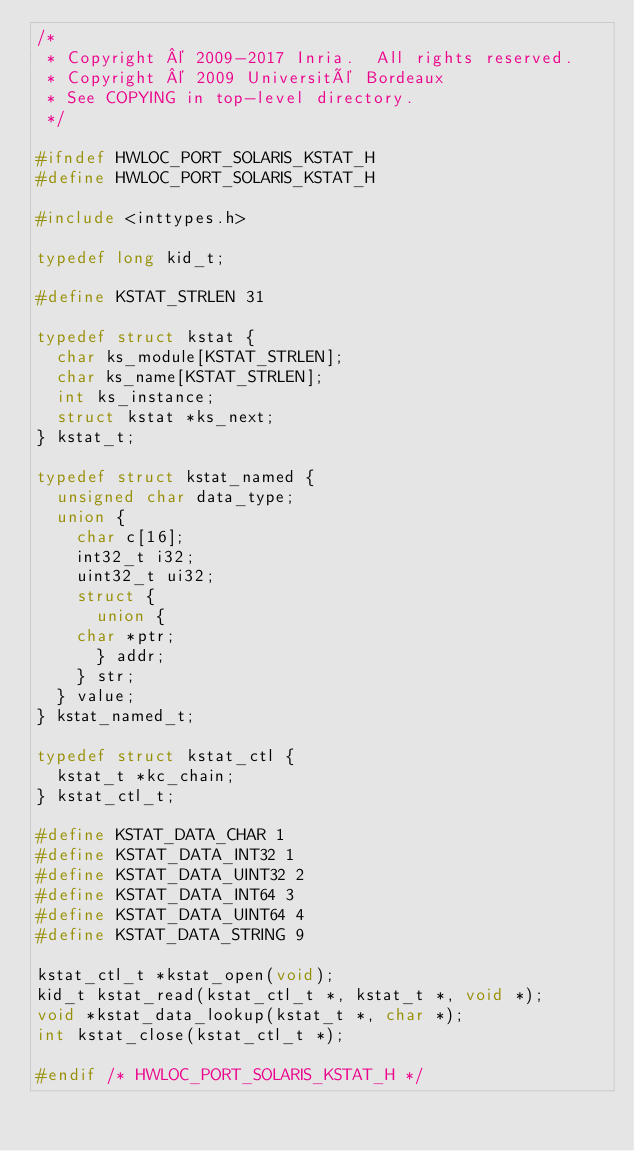Convert code to text. <code><loc_0><loc_0><loc_500><loc_500><_C_>/*
 * Copyright © 2009-2017 Inria.  All rights reserved.
 * Copyright © 2009 Université Bordeaux
 * See COPYING in top-level directory.
 */

#ifndef HWLOC_PORT_SOLARIS_KSTAT_H
#define HWLOC_PORT_SOLARIS_KSTAT_H

#include <inttypes.h>

typedef long kid_t;

#define KSTAT_STRLEN 31

typedef struct kstat {
  char ks_module[KSTAT_STRLEN];
  char ks_name[KSTAT_STRLEN];
  int ks_instance;
  struct kstat *ks_next;
} kstat_t;

typedef struct kstat_named {
  unsigned char data_type;
  union {
    char c[16];
    int32_t i32;
    uint32_t ui32;
    struct {
      union {
	char *ptr;
      } addr;
    } str;
  } value;
} kstat_named_t;

typedef struct kstat_ctl {
  kstat_t *kc_chain;
} kstat_ctl_t;

#define KSTAT_DATA_CHAR 1
#define KSTAT_DATA_INT32 1
#define KSTAT_DATA_UINT32 2
#define KSTAT_DATA_INT64 3
#define KSTAT_DATA_UINT64 4
#define KSTAT_DATA_STRING 9

kstat_ctl_t *kstat_open(void);
kid_t kstat_read(kstat_ctl_t *, kstat_t *, void *);
void *kstat_data_lookup(kstat_t *, char *);
int kstat_close(kstat_ctl_t *);

#endif /* HWLOC_PORT_SOLARIS_KSTAT_H */
</code> 